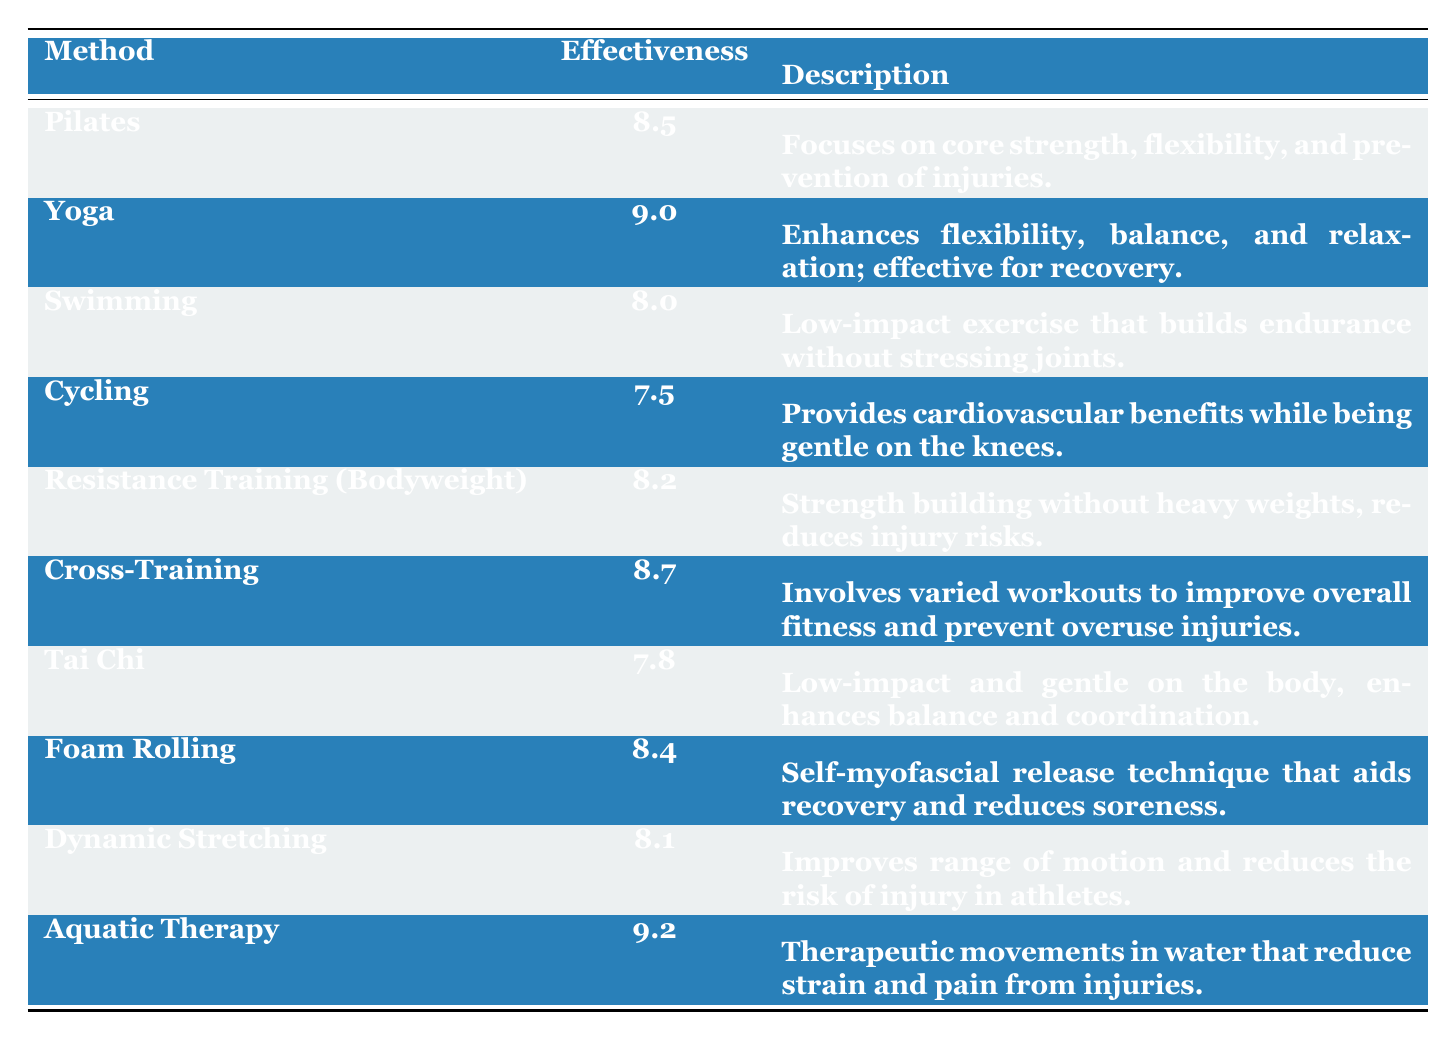What is the effectiveness rating of Yoga? The effectiveness rating of Yoga is directly stated in the table as **9.0**.
Answer: 9.0 Which training method has the highest effectiveness rating? The table indicates that Aquatic Therapy has the highest effectiveness rating at **9.2**.
Answer: Aquatic Therapy What is the effectiveness rating of Cycling? According to the table, Cycling has an effectiveness rating of **7.5**.
Answer: 7.5 How does the effectiveness rating of Tai Chi compare to that of Pilates? Tai Chi has an effectiveness rating of **7.8**, while Pilates has a rating of **8.5**; thus, Pilates is higher by **0.7**.
Answer: Pilates is higher by 0.7 If I add the effectiveness ratings of Resistance Training (Bodyweight) and Dynamic Stretching, what do I get? Resistance Training (Bodyweight) has an effectiveness rating of **8.2** and Dynamic Stretching has **8.1**. Adding these gives **16.3**.
Answer: 16.3 Is the effectiveness rating of Swimming greater than that of Cycling? Swimming has an effectiveness rating of **8.0** and Cycling has **7.5**; therefore, Swimming's rating is greater.
Answer: Yes What is the average effectiveness rating of all the training methods listed? To find the average, add all the effectiveness ratings (*8.5 + 9.0 + 8.0 + 7.5 + 8.2 + 8.7 + 7.8 + 8.4 + 8.1 + 9.2* = **84.2**) and then divide by the number of methods (10): **84.2/10 = 8.42**.
Answer: 8.42 Which method is described as enhancing flexibility, balance, and relaxation? The table states that Yoga is effective for enhancing flexibility, balance, and relaxation.
Answer: Yoga Which methods have effectiveness ratings above 8.0? The methods with ratings above 8.0 are: Yoga (**9.0**), Aquatic Therapy (**9.2**), Cross-Training (**8.7**), Pilates (**8.5**), and Foam Rolling (**8.4**).
Answer: 5 methods What is the difference between the effectiveness ratings of Dynamic Stretching and Tai Chi? Dynamic Stretching has an effectiveness rating of **8.1**, while Tai Chi has **7.8**. The difference is **0.3**, with Dynamic Stretching being higher.
Answer: 0.3 